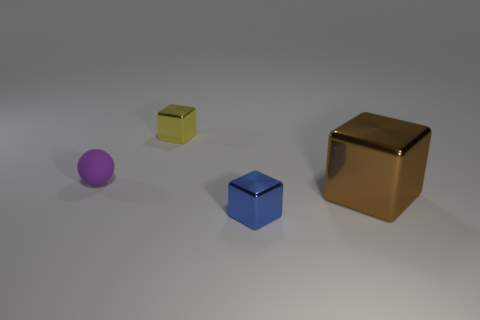Is there any other thing that is the same material as the purple ball?
Make the answer very short. No. What is the shape of the tiny shiny thing that is to the left of the tiny thing that is on the right side of the yellow cube?
Your answer should be compact. Cube. Is there a cyan metal thing of the same shape as the tiny yellow object?
Keep it short and to the point. No. Is the color of the tiny rubber object the same as the small block that is behind the small sphere?
Provide a short and direct response. No. Are there any cyan cylinders that have the same size as the sphere?
Provide a succinct answer. No. Does the brown block have the same material as the small cube in front of the matte thing?
Your answer should be compact. Yes. Is the number of big purple balls greater than the number of small yellow blocks?
Your answer should be very brief. No. How many spheres are yellow metal things or tiny rubber things?
Your response must be concise. 1. The tiny rubber sphere has what color?
Keep it short and to the point. Purple. There is a cube that is behind the large metal object; is it the same size as the matte thing that is in front of the yellow block?
Your response must be concise. Yes. 